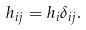<formula> <loc_0><loc_0><loc_500><loc_500>h _ { i j } = h _ { i } \delta _ { i j } .</formula> 